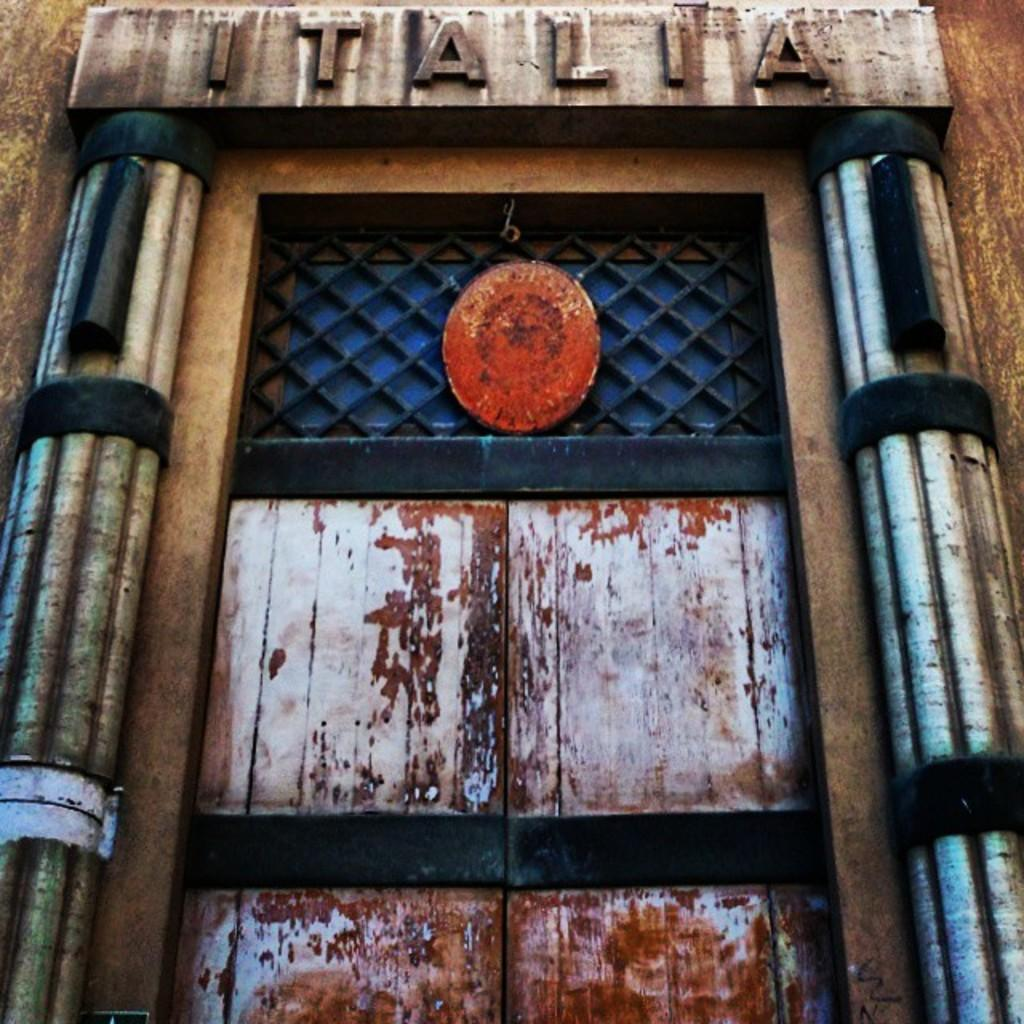What is one of the main features of the image? There is a door in the image. Can you describe any specific details about the door? There is a name at the top of the door. What type of activity is happening with the cows in the image? There are no cows present in the image, so no activity involving cows can be observed. What flavor of jam is being spread on the door in the image? There is no jam present in the image, and the door is not being used for spreading jam. 